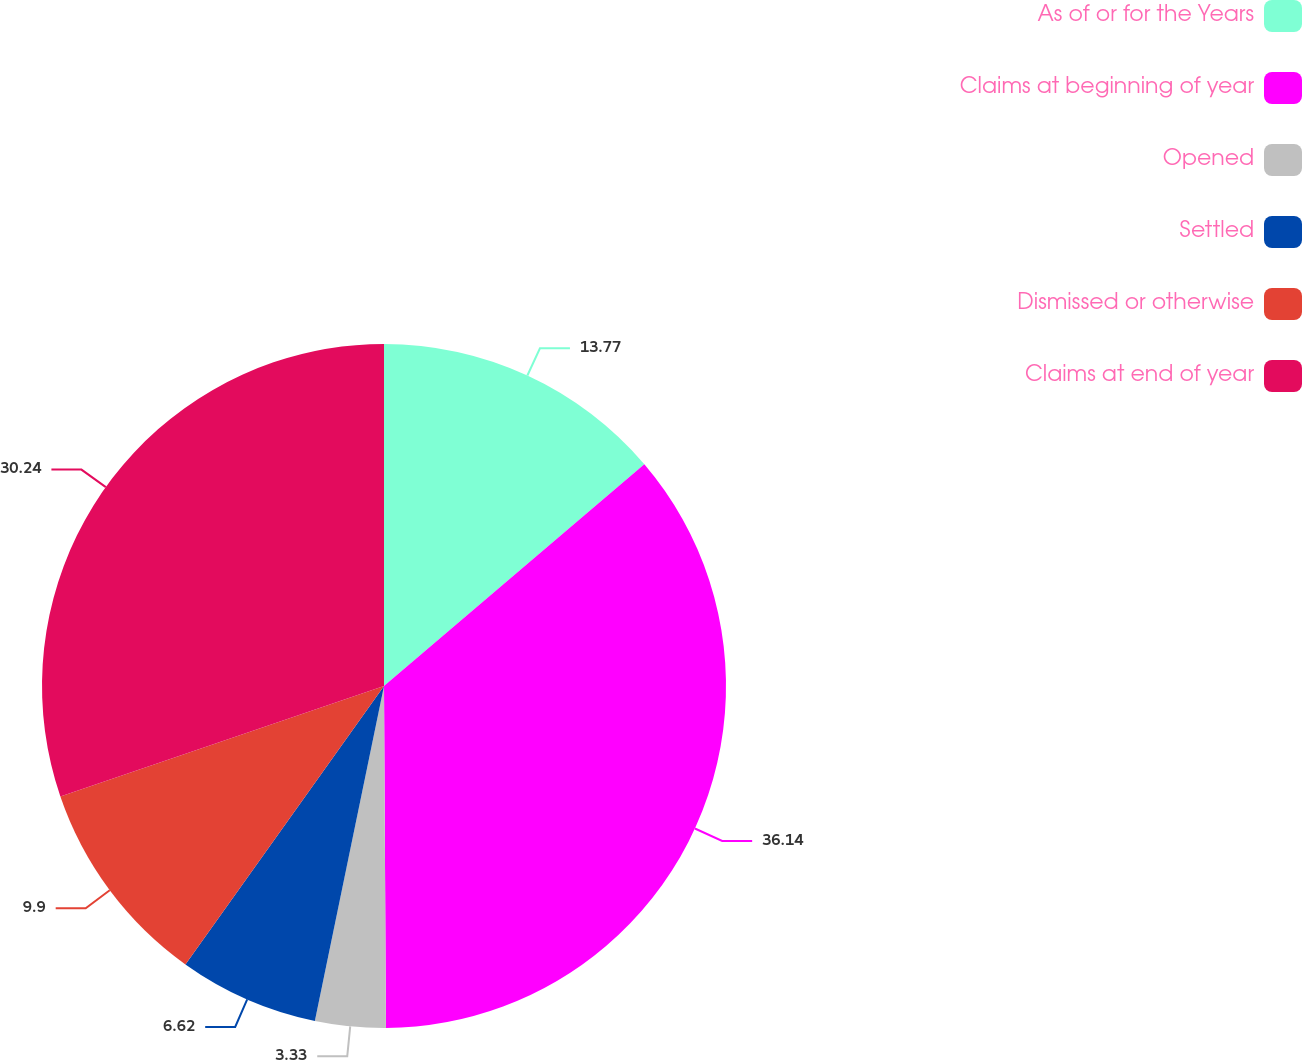Convert chart. <chart><loc_0><loc_0><loc_500><loc_500><pie_chart><fcel>As of or for the Years<fcel>Claims at beginning of year<fcel>Opened<fcel>Settled<fcel>Dismissed or otherwise<fcel>Claims at end of year<nl><fcel>13.77%<fcel>36.14%<fcel>3.33%<fcel>6.62%<fcel>9.9%<fcel>30.24%<nl></chart> 